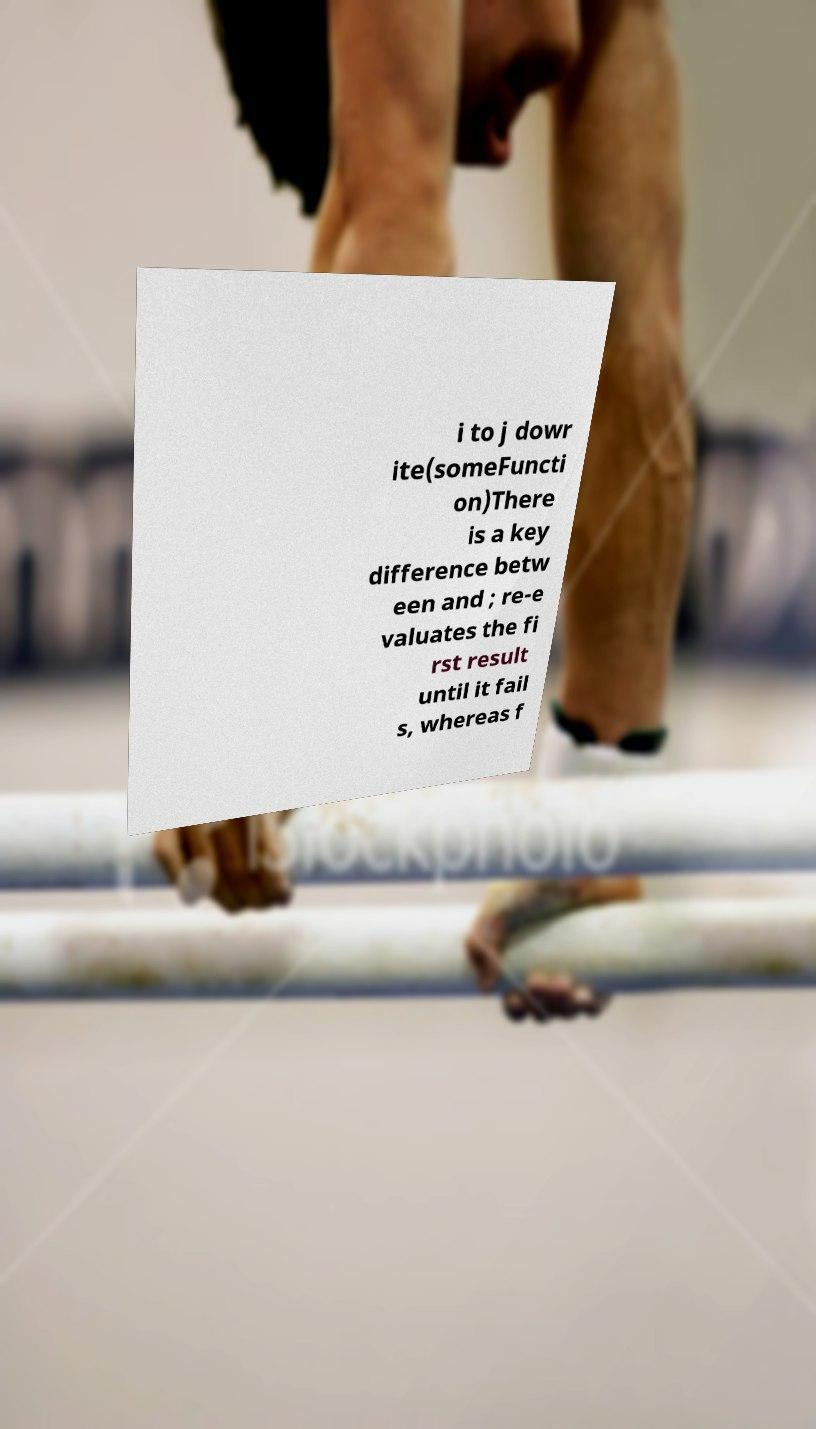Can you accurately transcribe the text from the provided image for me? i to j dowr ite(someFuncti on)There is a key difference betw een and ; re-e valuates the fi rst result until it fail s, whereas f 